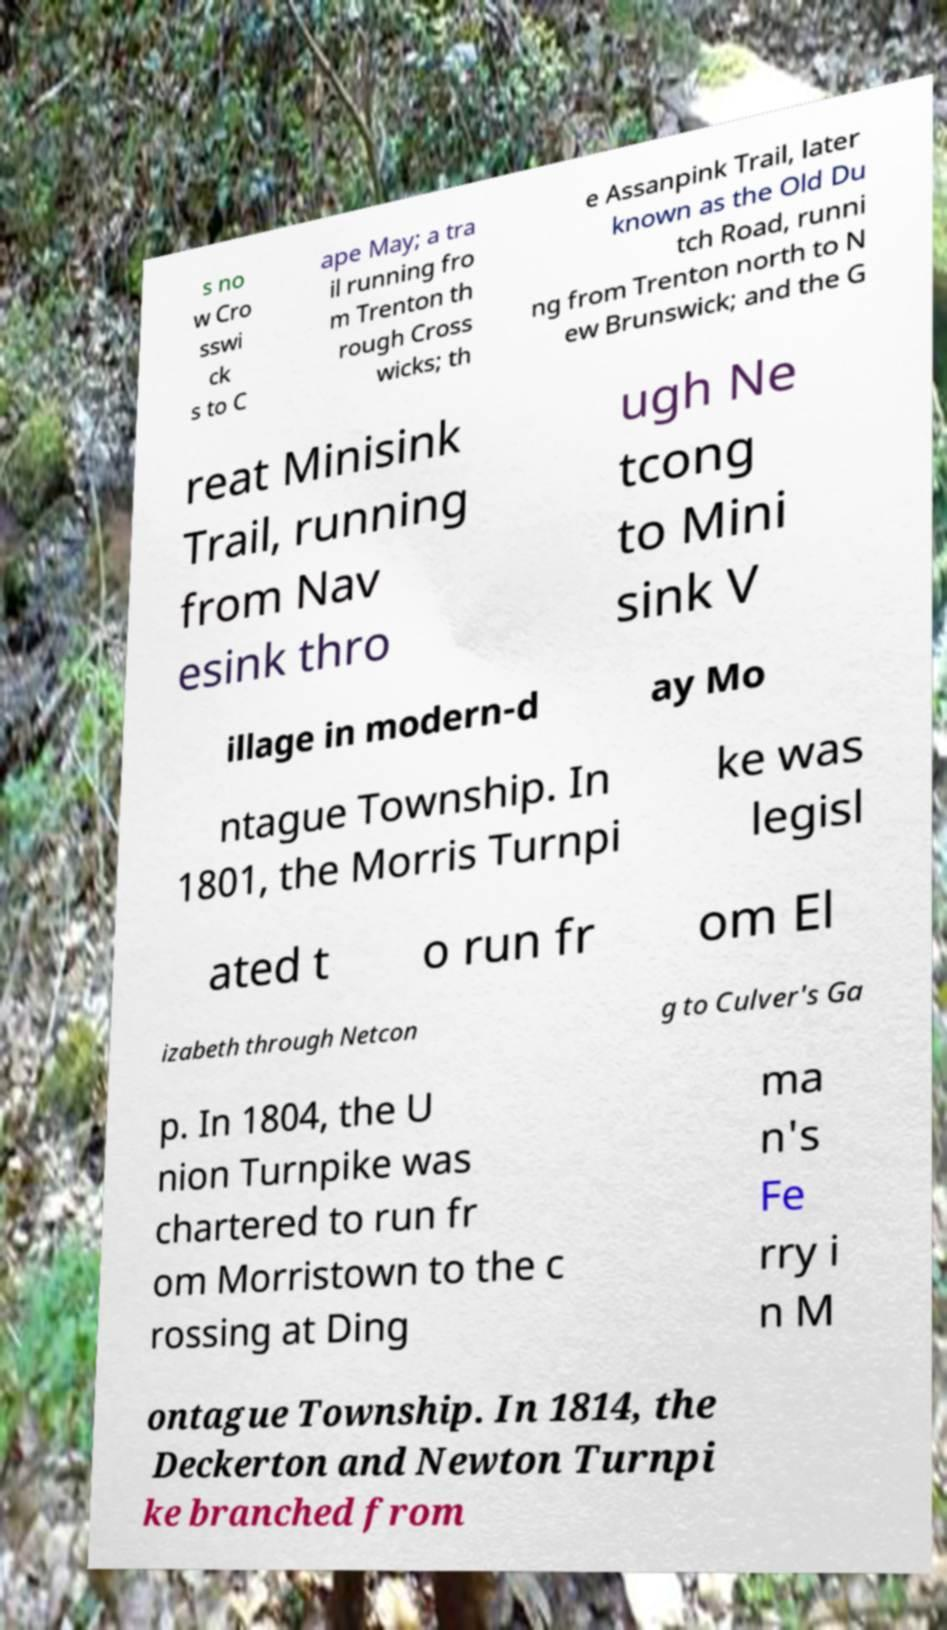Could you extract and type out the text from this image? s no w Cro sswi ck s to C ape May; a tra il running fro m Trenton th rough Cross wicks; th e Assanpink Trail, later known as the Old Du tch Road, runni ng from Trenton north to N ew Brunswick; and the G reat Minisink Trail, running from Nav esink thro ugh Ne tcong to Mini sink V illage in modern-d ay Mo ntague Township. In 1801, the Morris Turnpi ke was legisl ated t o run fr om El izabeth through Netcon g to Culver's Ga p. In 1804, the U nion Turnpike was chartered to run fr om Morristown to the c rossing at Ding ma n's Fe rry i n M ontague Township. In 1814, the Deckerton and Newton Turnpi ke branched from 